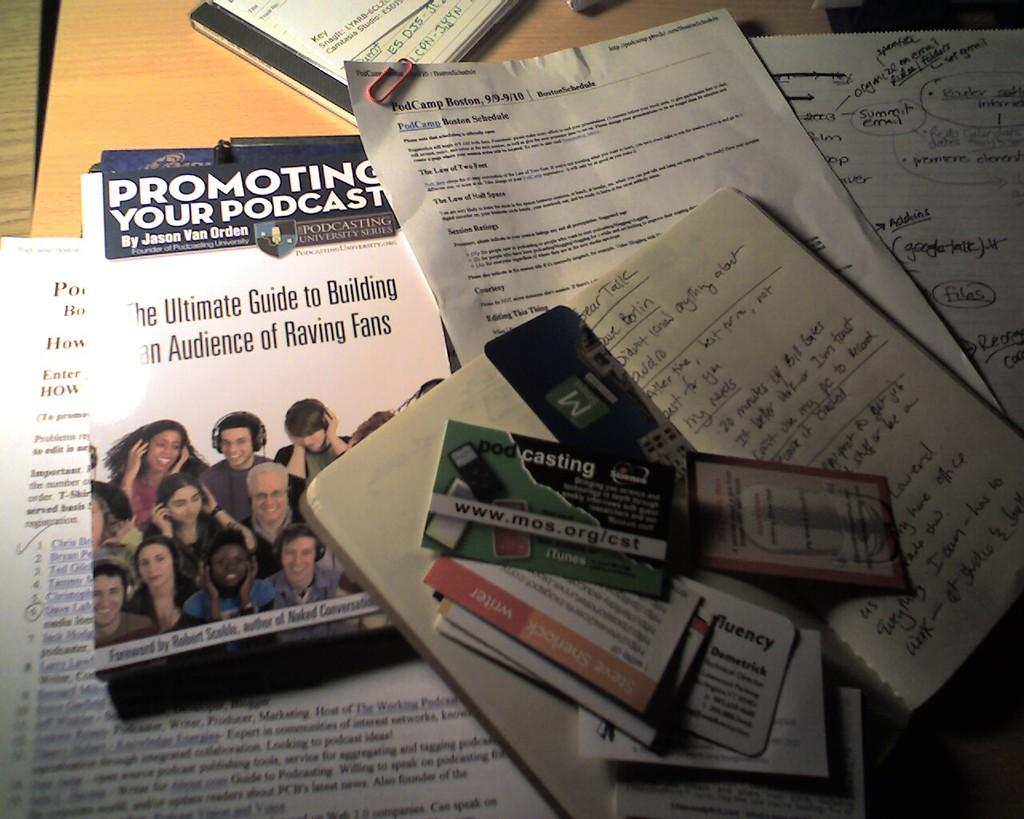Provide a one-sentence caption for the provided image. Promoting your podcast pamphlet, cards, papers, and handwritten notes.. 